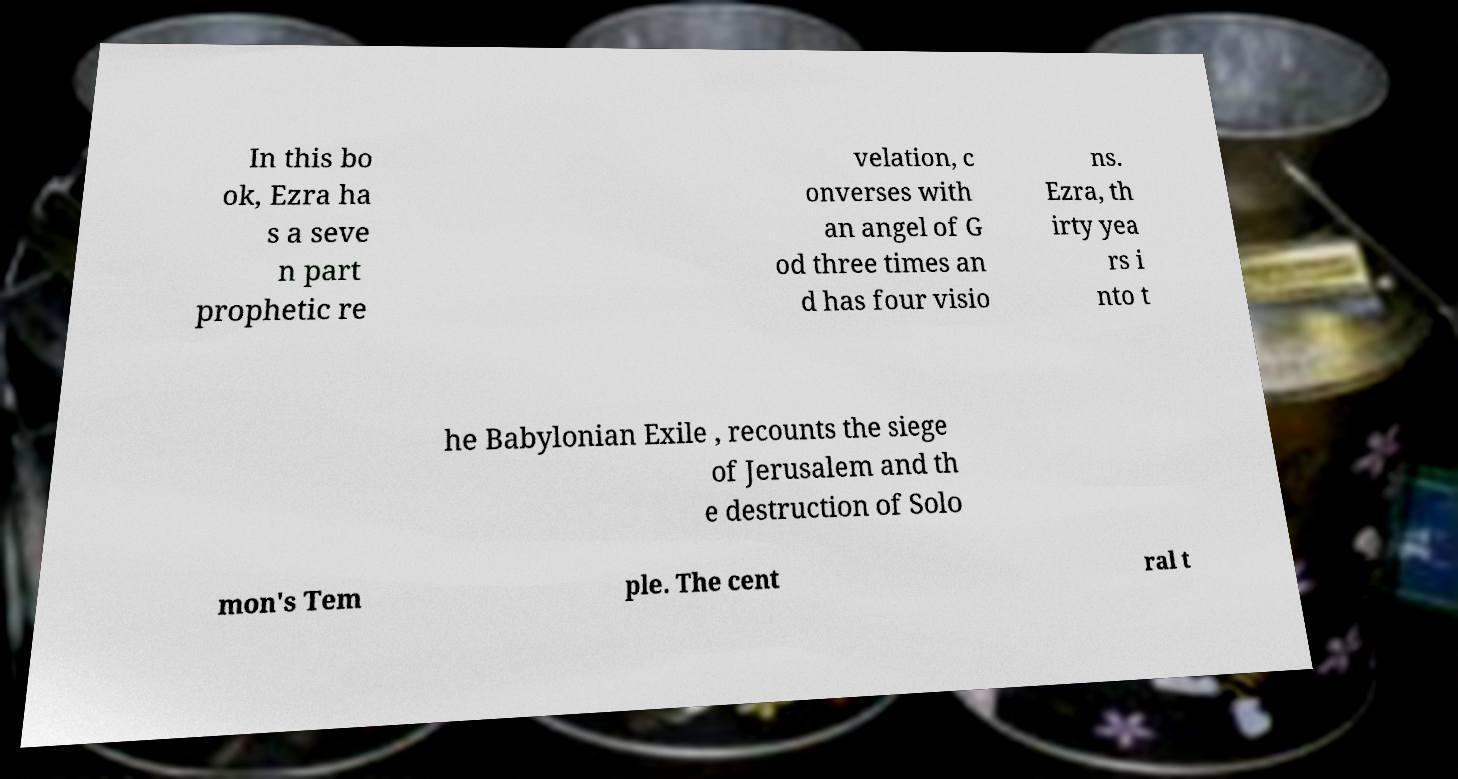Can you read and provide the text displayed in the image?This photo seems to have some interesting text. Can you extract and type it out for me? In this bo ok, Ezra ha s a seve n part prophetic re velation, c onverses with an angel of G od three times an d has four visio ns. Ezra, th irty yea rs i nto t he Babylonian Exile , recounts the siege of Jerusalem and th e destruction of Solo mon's Tem ple. The cent ral t 